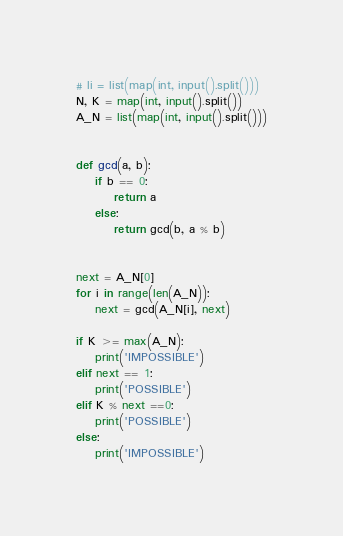<code> <loc_0><loc_0><loc_500><loc_500><_Python_># li = list(map(int, input().split()))
N, K = map(int, input().split())
A_N = list(map(int, input().split()))


def gcd(a, b):
    if b == 0:
        return a
    else:
        return gcd(b, a % b)


next = A_N[0]
for i in range(len(A_N)):
    next = gcd(A_N[i], next)

if K >= max(A_N):
    print('IMPOSSIBLE')
elif next == 1:
    print('POSSIBLE')
elif K % next ==0:
    print('POSSIBLE')
else:
    print('IMPOSSIBLE')</code> 